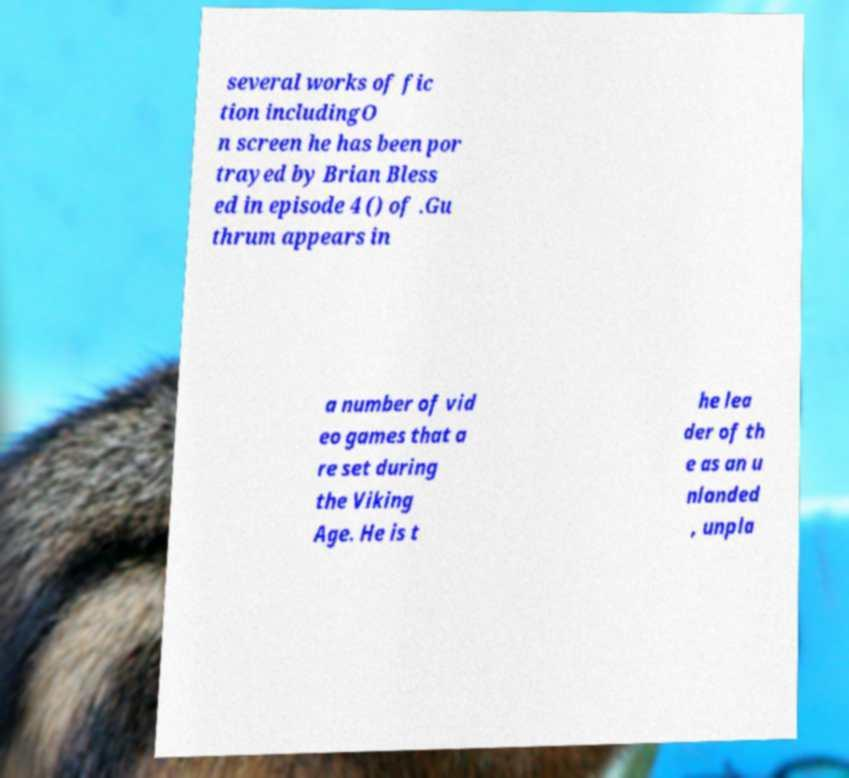Could you assist in decoding the text presented in this image and type it out clearly? several works of fic tion includingO n screen he has been por trayed by Brian Bless ed in episode 4 () of .Gu thrum appears in a number of vid eo games that a re set during the Viking Age. He is t he lea der of th e as an u nlanded , unpla 